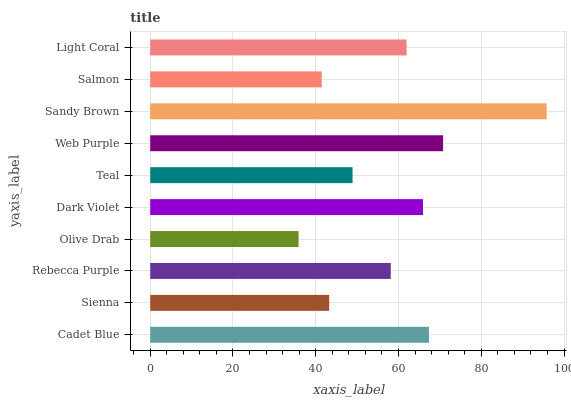Is Olive Drab the minimum?
Answer yes or no. Yes. Is Sandy Brown the maximum?
Answer yes or no. Yes. Is Sienna the minimum?
Answer yes or no. No. Is Sienna the maximum?
Answer yes or no. No. Is Cadet Blue greater than Sienna?
Answer yes or no. Yes. Is Sienna less than Cadet Blue?
Answer yes or no. Yes. Is Sienna greater than Cadet Blue?
Answer yes or no. No. Is Cadet Blue less than Sienna?
Answer yes or no. No. Is Light Coral the high median?
Answer yes or no. Yes. Is Rebecca Purple the low median?
Answer yes or no. Yes. Is Sandy Brown the high median?
Answer yes or no. No. Is Sienna the low median?
Answer yes or no. No. 